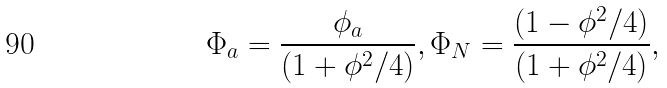<formula> <loc_0><loc_0><loc_500><loc_500>\Phi _ { a } = \frac { { \phi _ { a } } } { ( 1 + \phi ^ { 2 } / 4 ) } , \Phi _ { N } = \frac { { ( 1 - \phi ^ { 2 } / 4 ) } } { ( 1 + \phi ^ { 2 } / 4 ) } ,</formula> 